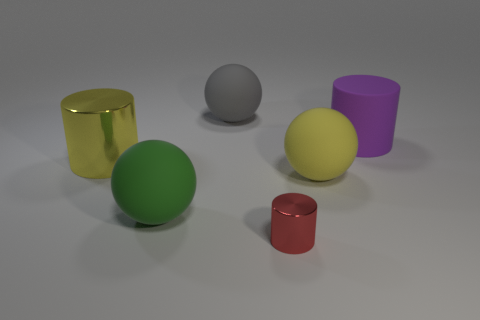Are there an equal number of big yellow matte things that are in front of the big green matte ball and yellow shiny cylinders?
Make the answer very short. No. There is a purple matte cylinder; is its size the same as the shiny cylinder behind the large yellow matte object?
Provide a short and direct response. Yes. How many other big cylinders are made of the same material as the purple cylinder?
Provide a short and direct response. 0. Is the size of the red object the same as the purple rubber cylinder?
Provide a succinct answer. No. Is there anything else that has the same color as the large matte cylinder?
Your answer should be very brief. No. There is a object that is left of the small cylinder and behind the big yellow metal cylinder; what is its shape?
Provide a short and direct response. Sphere. There is a purple cylinder that is behind the large green ball; what is its size?
Make the answer very short. Large. There is a yellow object to the left of the big sphere behind the purple cylinder; how many yellow rubber things are behind it?
Offer a terse response. 0. Are there any big purple matte objects left of the large matte cylinder?
Give a very brief answer. No. What number of other objects are there of the same size as the green ball?
Provide a succinct answer. 4. 